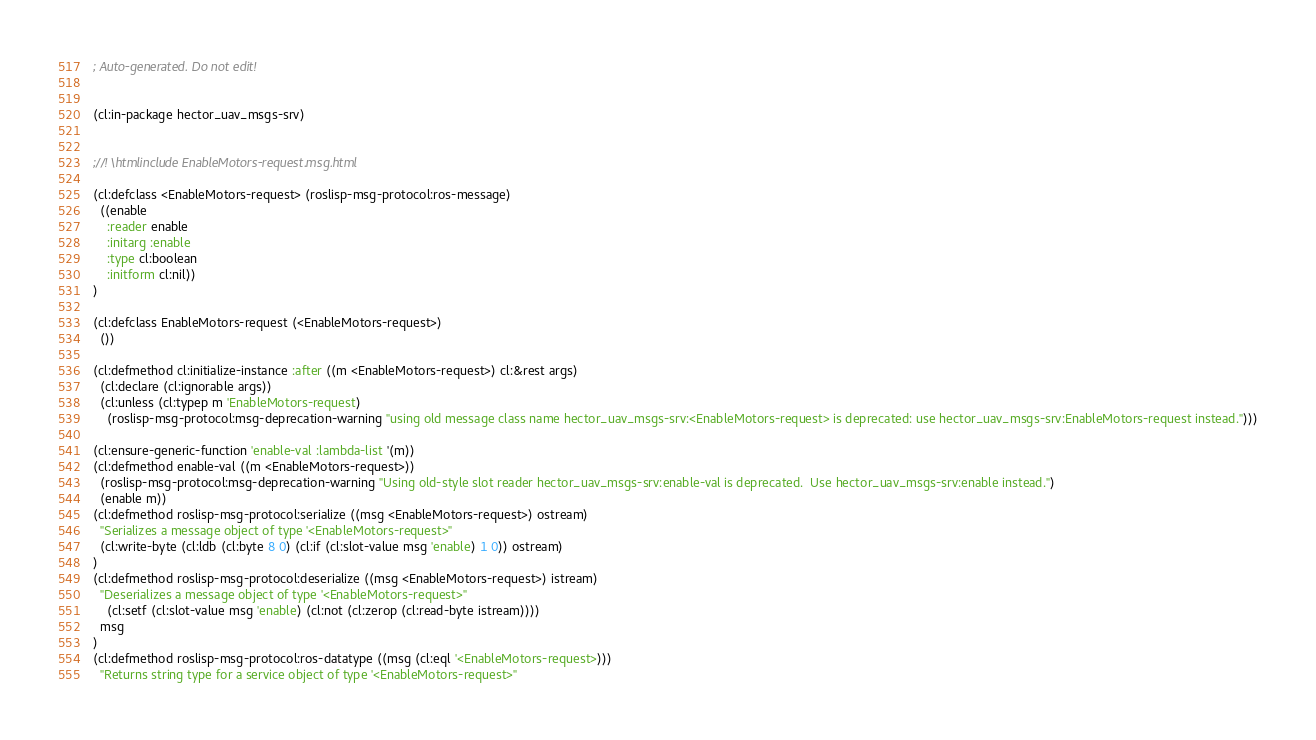Convert code to text. <code><loc_0><loc_0><loc_500><loc_500><_Lisp_>; Auto-generated. Do not edit!


(cl:in-package hector_uav_msgs-srv)


;//! \htmlinclude EnableMotors-request.msg.html

(cl:defclass <EnableMotors-request> (roslisp-msg-protocol:ros-message)
  ((enable
    :reader enable
    :initarg :enable
    :type cl:boolean
    :initform cl:nil))
)

(cl:defclass EnableMotors-request (<EnableMotors-request>)
  ())

(cl:defmethod cl:initialize-instance :after ((m <EnableMotors-request>) cl:&rest args)
  (cl:declare (cl:ignorable args))
  (cl:unless (cl:typep m 'EnableMotors-request)
    (roslisp-msg-protocol:msg-deprecation-warning "using old message class name hector_uav_msgs-srv:<EnableMotors-request> is deprecated: use hector_uav_msgs-srv:EnableMotors-request instead.")))

(cl:ensure-generic-function 'enable-val :lambda-list '(m))
(cl:defmethod enable-val ((m <EnableMotors-request>))
  (roslisp-msg-protocol:msg-deprecation-warning "Using old-style slot reader hector_uav_msgs-srv:enable-val is deprecated.  Use hector_uav_msgs-srv:enable instead.")
  (enable m))
(cl:defmethod roslisp-msg-protocol:serialize ((msg <EnableMotors-request>) ostream)
  "Serializes a message object of type '<EnableMotors-request>"
  (cl:write-byte (cl:ldb (cl:byte 8 0) (cl:if (cl:slot-value msg 'enable) 1 0)) ostream)
)
(cl:defmethod roslisp-msg-protocol:deserialize ((msg <EnableMotors-request>) istream)
  "Deserializes a message object of type '<EnableMotors-request>"
    (cl:setf (cl:slot-value msg 'enable) (cl:not (cl:zerop (cl:read-byte istream))))
  msg
)
(cl:defmethod roslisp-msg-protocol:ros-datatype ((msg (cl:eql '<EnableMotors-request>)))
  "Returns string type for a service object of type '<EnableMotors-request>"</code> 